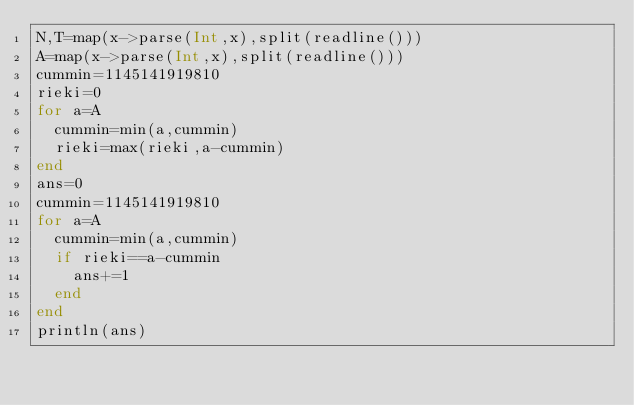<code> <loc_0><loc_0><loc_500><loc_500><_Julia_>N,T=map(x->parse(Int,x),split(readline()))
A=map(x->parse(Int,x),split(readline()))
cummin=1145141919810
rieki=0
for a=A
  cummin=min(a,cummin)
  rieki=max(rieki,a-cummin)
end
ans=0
cummin=1145141919810
for a=A
  cummin=min(a,cummin)
  if rieki==a-cummin
    ans+=1
  end
end
println(ans)</code> 